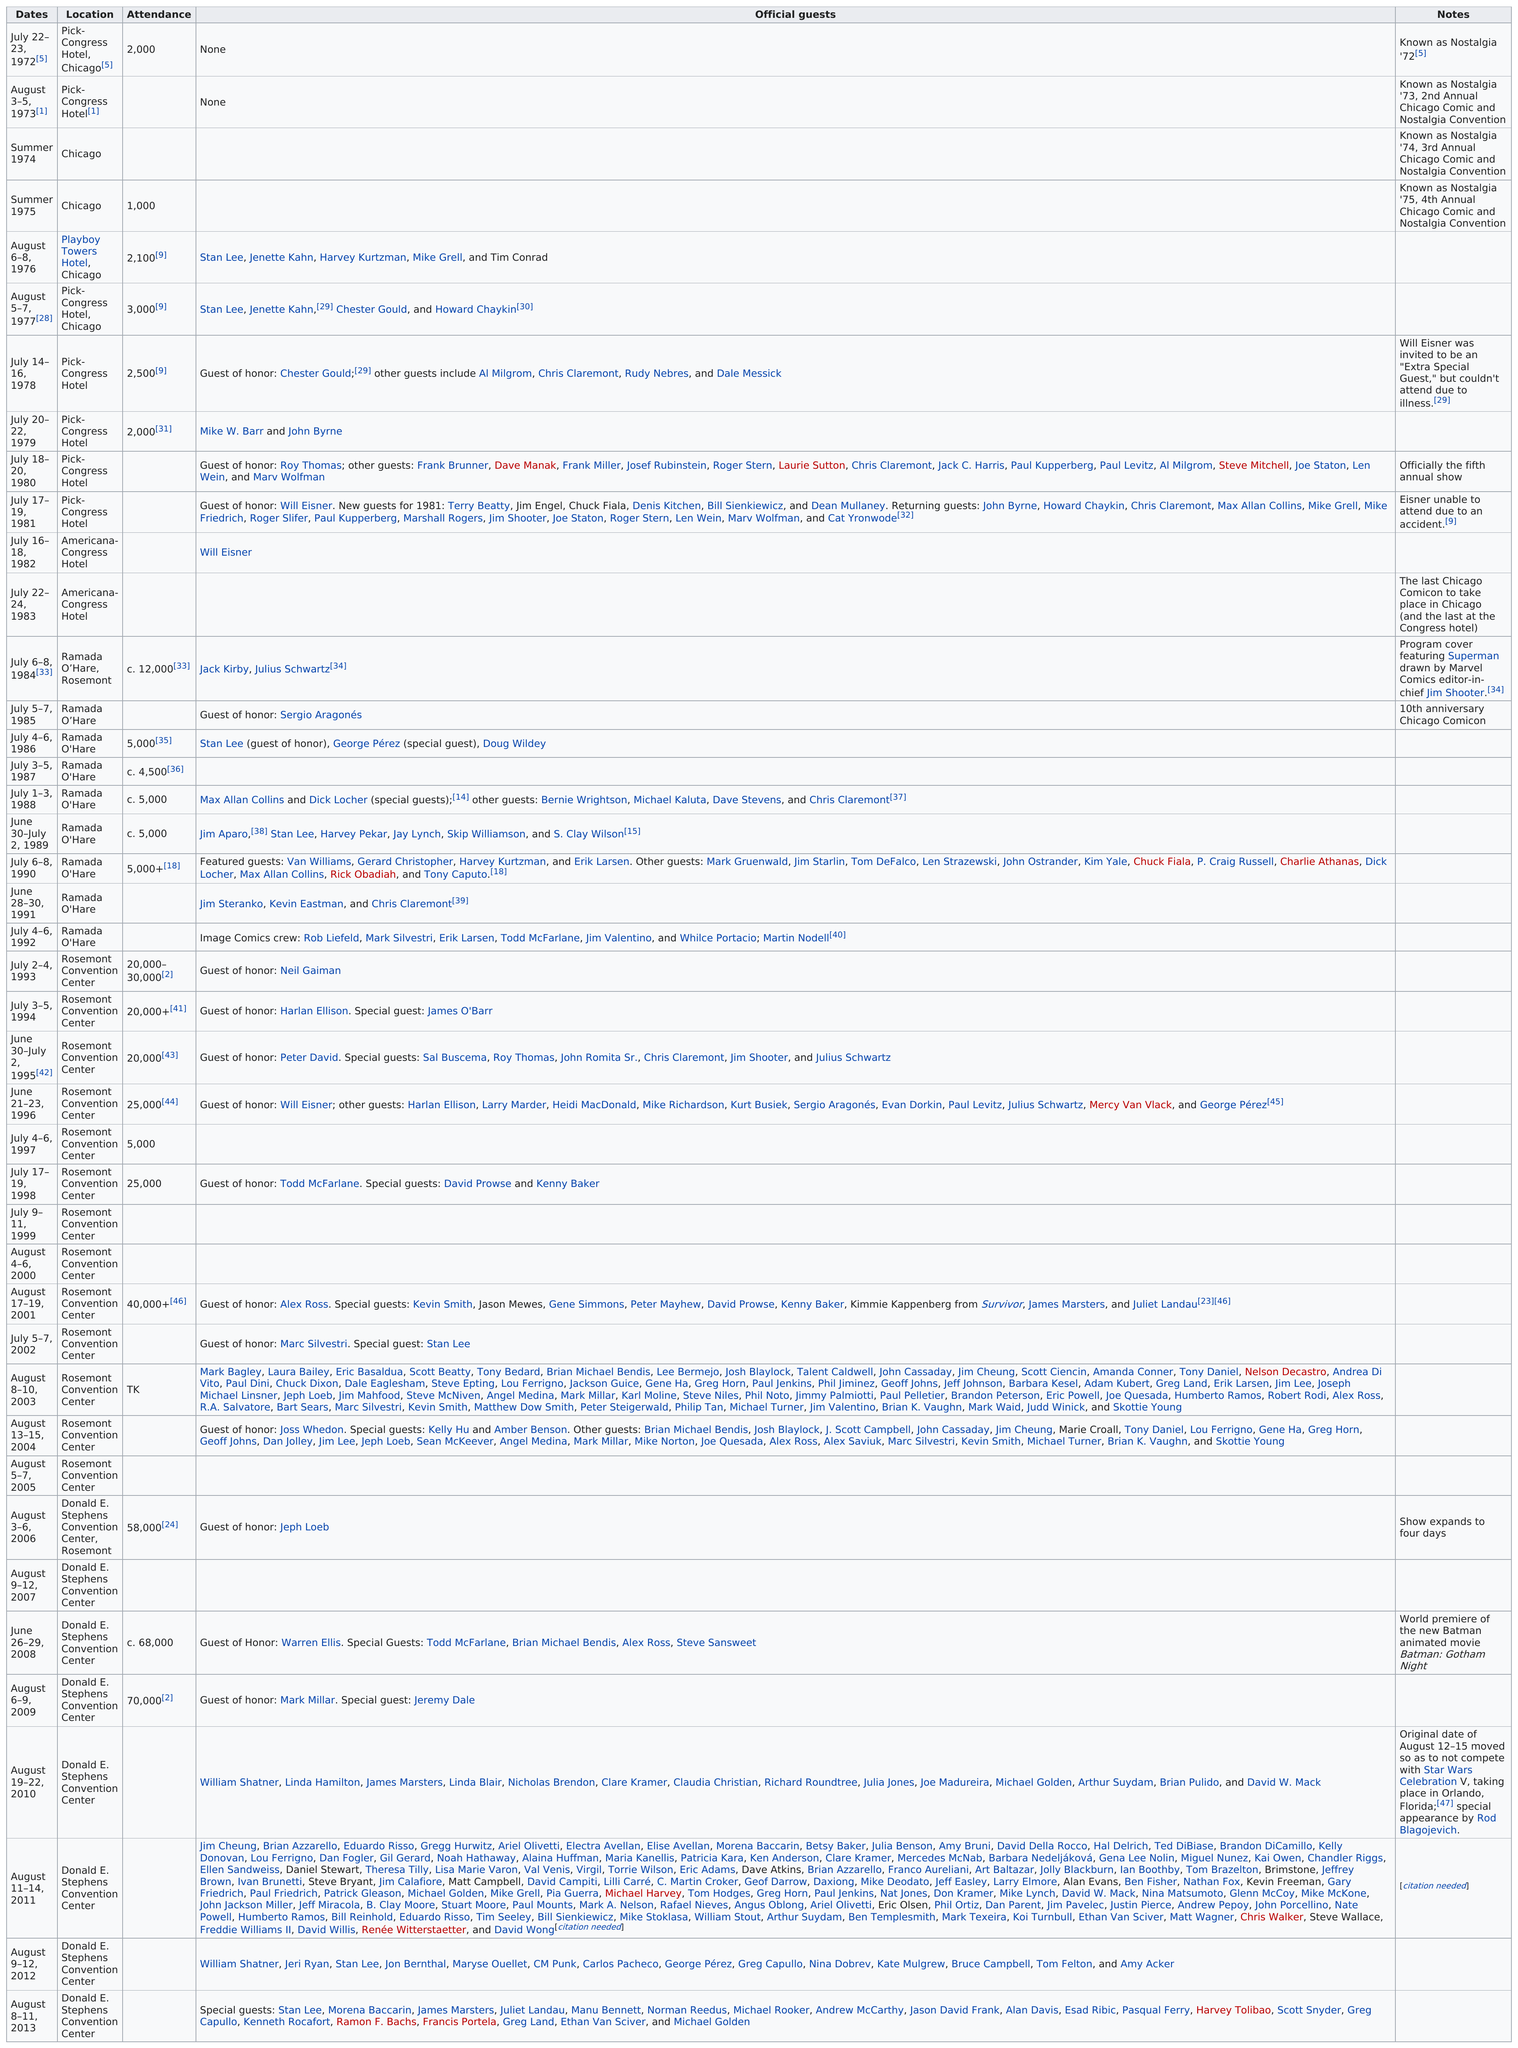Indicate a few pertinent items in this graphic. There were no official guests at the event that took place on July 22-23, 1972. The location of the next event after the summer 1975 gathering was the Playboy Towers Hotel in Chicago. The event was first held at the Pick-Congress Hotel in Chicago in 1972. In 2013, there were more official guests than in 2012. The first date that had official guests was August 6-8, 1976. 